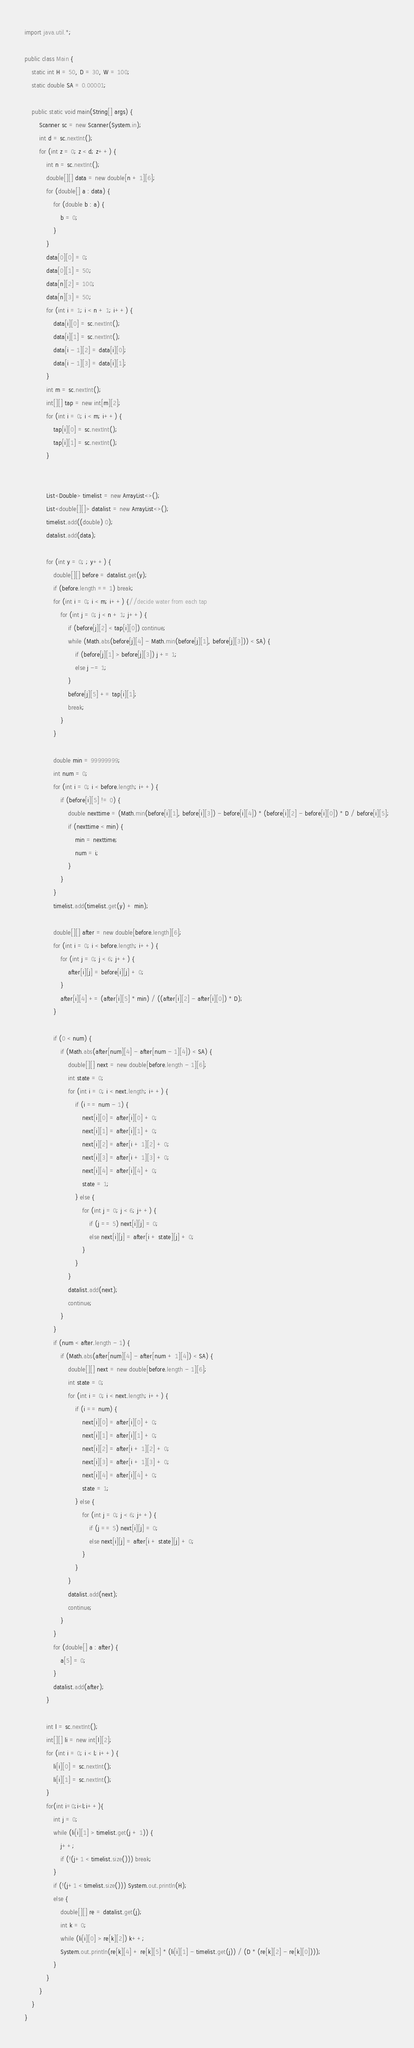<code> <loc_0><loc_0><loc_500><loc_500><_Java_>import java.util.*;

public class Main {
    static int H = 50, D = 30, W = 100;
    static double SA = 0.00001;

    public static void main(String[] args) {
        Scanner sc = new Scanner(System.in);
        int d = sc.nextInt();
        for (int z = 0; z < d; z++) {
            int n = sc.nextInt();
            double[][] data = new double[n + 1][6];
            for (double[] a : data) {
                for (double b : a) {
                    b = 0;
                }
            }
            data[0][0] = 0;
            data[0][1] = 50;
            data[n][2] = 100;
            data[n][3] = 50;
            for (int i = 1; i < n + 1; i++) {
                data[i][0] = sc.nextInt();
                data[i][1] = sc.nextInt();
                data[i - 1][2] = data[i][0];
                data[i - 1][3] = data[i][1];
            }
            int m = sc.nextInt();
            int[][] tap = new int[m][2];
            for (int i = 0; i < m; i++) {
                tap[i][0] = sc.nextInt();
                tap[i][1] = sc.nextInt();
            }


            List<Double> timelist = new ArrayList<>();
            List<double[][]> datalist = new ArrayList<>();
            timelist.add((double) 0);
            datalist.add(data);

            for (int y = 0; ; y++) {
                double[][] before = datalist.get(y);
                if (before.length == 1) break;
                for (int i = 0; i < m; i++) {//decide water from each tap
                    for (int j = 0; j < n + 1; j++) {
                        if (before[j][2] < tap[i][0]) continue;
                        while (Math.abs(before[j][4] - Math.min(before[j][1], before[j][3])) < SA) {
                            if (before[j][1] > before[j][3]) j += 1;
                            else j -= 1;
                        }
                        before[j][5] += tap[i][1];
                        break;
                    }
                }

                double min = 99999999;
                int num = 0;
                for (int i = 0; i < before.length; i++) {
                    if (before[i][5] != 0) {
                        double nexttime = (Math.min(before[i][1], before[i][3]) - before[i][4]) * (before[i][2] - before[i][0]) * D / before[i][5];
                        if (nexttime < min) {
                            min = nexttime;
                            num = i;
                        }
                    }
                }
                timelist.add(timelist.get(y) + min);

                double[][] after = new double[before.length][6];
                for (int i = 0; i < before.length; i++) {
                    for (int j = 0; j < 6; j++) {
                        after[i][j] = before[i][j] + 0;
                    }
                    after[i][4] += (after[i][5] * min) / ((after[i][2] - after[i][0]) * D);
                }

                if (0 < num) {
                    if (Math.abs(after[num][4] - after[num - 1][4]) < SA) {
                        double[][] next = new double[before.length - 1][6];
                        int state = 0;
                        for (int i = 0; i < next.length; i++) {
                            if (i == num - 1) {
                                next[i][0] = after[i][0] + 0;
                                next[i][1] = after[i][1] + 0;
                                next[i][2] = after[i + 1][2] + 0;
                                next[i][3] = after[i + 1][3] + 0;
                                next[i][4] = after[i][4] + 0;
                                state = 1;
                            } else {
                                for (int j = 0; j < 6; j++) {
                                    if (j == 5) next[i][j] = 0;
                                    else next[i][j] = after[i + state][j] + 0;
                                }
                            }
                        }
                        datalist.add(next);
                        continue;
                    }
                }
                if (num < after.length - 1) {
                    if (Math.abs(after[num][4] - after[num + 1][4]) < SA) {
                        double[][] next = new double[before.length - 1][6];
                        int state = 0;
                        for (int i = 0; i < next.length; i++) {
                            if (i == num) {
                                next[i][0] = after[i][0] + 0;
                                next[i][1] = after[i][1] + 0;
                                next[i][2] = after[i + 1][2] + 0;
                                next[i][3] = after[i + 1][3] + 0;
                                next[i][4] = after[i][4] + 0;
                                state = 1;
                            } else {
                                for (int j = 0; j < 6; j++) {
                                    if (j == 5) next[i][j] = 0;
                                    else next[i][j] = after[i + state][j] + 0;
                                }
                            }
                        }
                        datalist.add(next);
                        continue;
                    }
                }
                for (double[] a : after) {
                    a[5] = 0;
                }
                datalist.add(after);
            }

            int l = sc.nextInt();
            int[][] li = new int[l][2];
            for (int i = 0; i < l; i++) {
                li[i][0] = sc.nextInt();
                li[i][1] = sc.nextInt();
            }
            for(int i=0;i<l;i++){
                int j = 0;
                while (li[i][1] > timelist.get(j + 1)) {
                    j++;
                    if (!(j+1 < timelist.size())) break;
                }
                if (!(j+1 < timelist.size())) System.out.println(H);
                else {
                    double[][] re = datalist.get(j);
                    int k = 0;
                    while (li[i][0] > re[k][2]) k++;
                    System.out.println(re[k][4] + re[k][5] * (li[i][1] - timelist.get(j)) / (D * (re[k][2] - re[k][0])));
                }
            }
        }
    }
}
</code> 